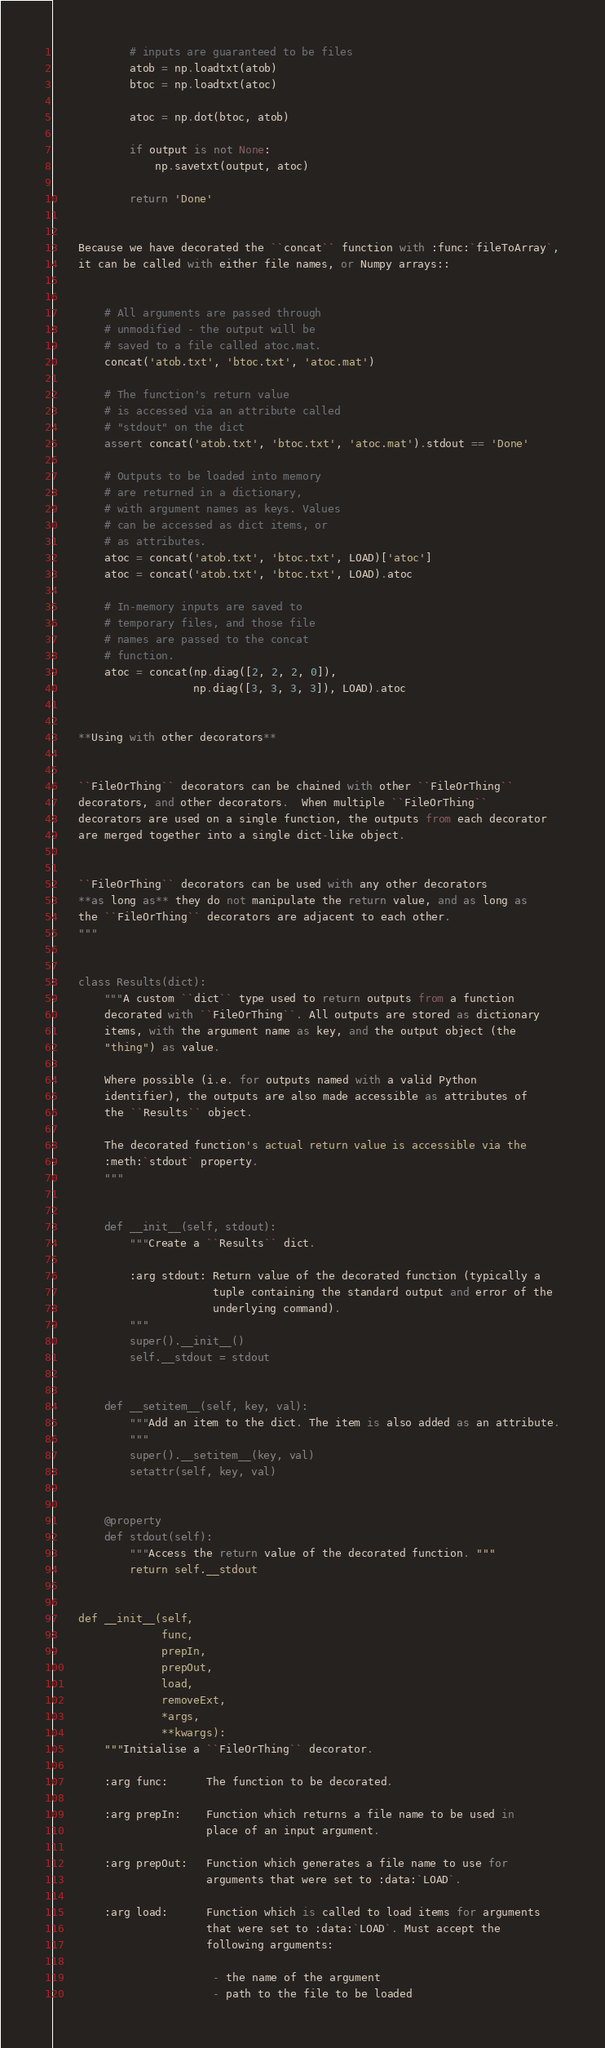Convert code to text. <code><loc_0><loc_0><loc_500><loc_500><_Python_>
            # inputs are guaranteed to be files
            atob = np.loadtxt(atob)
            btoc = np.loadtxt(atoc)

            atoc = np.dot(btoc, atob)

            if output is not None:
                np.savetxt(output, atoc)

            return 'Done'


    Because we have decorated the ``concat`` function with :func:`fileToArray`,
    it can be called with either file names, or Numpy arrays::


        # All arguments are passed through
        # unmodified - the output will be
        # saved to a file called atoc.mat.
        concat('atob.txt', 'btoc.txt', 'atoc.mat')

        # The function's return value
        # is accessed via an attribute called
        # "stdout" on the dict
        assert concat('atob.txt', 'btoc.txt', 'atoc.mat').stdout == 'Done'

        # Outputs to be loaded into memory
        # are returned in a dictionary,
        # with argument names as keys. Values
        # can be accessed as dict items, or
        # as attributes.
        atoc = concat('atob.txt', 'btoc.txt', LOAD)['atoc']
        atoc = concat('atob.txt', 'btoc.txt', LOAD).atoc

        # In-memory inputs are saved to
        # temporary files, and those file
        # names are passed to the concat
        # function.
        atoc = concat(np.diag([2, 2, 2, 0]),
                      np.diag([3, 3, 3, 3]), LOAD).atoc


    **Using with other decorators**


    ``FileOrThing`` decorators can be chained with other ``FileOrThing``
    decorators, and other decorators.  When multiple ``FileOrThing``
    decorators are used on a single function, the outputs from each decorator
    are merged together into a single dict-like object.


    ``FileOrThing`` decorators can be used with any other decorators
    **as long as** they do not manipulate the return value, and as long as
    the ``FileOrThing`` decorators are adjacent to each other.
    """


    class Results(dict):
        """A custom ``dict`` type used to return outputs from a function
        decorated with ``FileOrThing``. All outputs are stored as dictionary
        items, with the argument name as key, and the output object (the
        "thing") as value.

        Where possible (i.e. for outputs named with a valid Python
        identifier), the outputs are also made accessible as attributes of
        the ``Results`` object.

        The decorated function's actual return value is accessible via the
        :meth:`stdout` property.
        """


        def __init__(self, stdout):
            """Create a ``Results`` dict.

            :arg stdout: Return value of the decorated function (typically a
                         tuple containing the standard output and error of the
                         underlying command).
            """
            super().__init__()
            self.__stdout = stdout


        def __setitem__(self, key, val):
            """Add an item to the dict. The item is also added as an attribute.
            """
            super().__setitem__(key, val)
            setattr(self, key, val)


        @property
        def stdout(self):
            """Access the return value of the decorated function. """
            return self.__stdout


    def __init__(self,
                 func,
                 prepIn,
                 prepOut,
                 load,
                 removeExt,
                 *args,
                 **kwargs):
        """Initialise a ``FileOrThing`` decorator.

        :arg func:      The function to be decorated.

        :arg prepIn:    Function which returns a file name to be used in
                        place of an input argument.

        :arg prepOut:   Function which generates a file name to use for
                        arguments that were set to :data:`LOAD`.

        :arg load:      Function which is called to load items for arguments
                        that were set to :data:`LOAD`. Must accept the
                        following arguments:

                         - the name of the argument
                         - path to the file to be loaded
</code> 